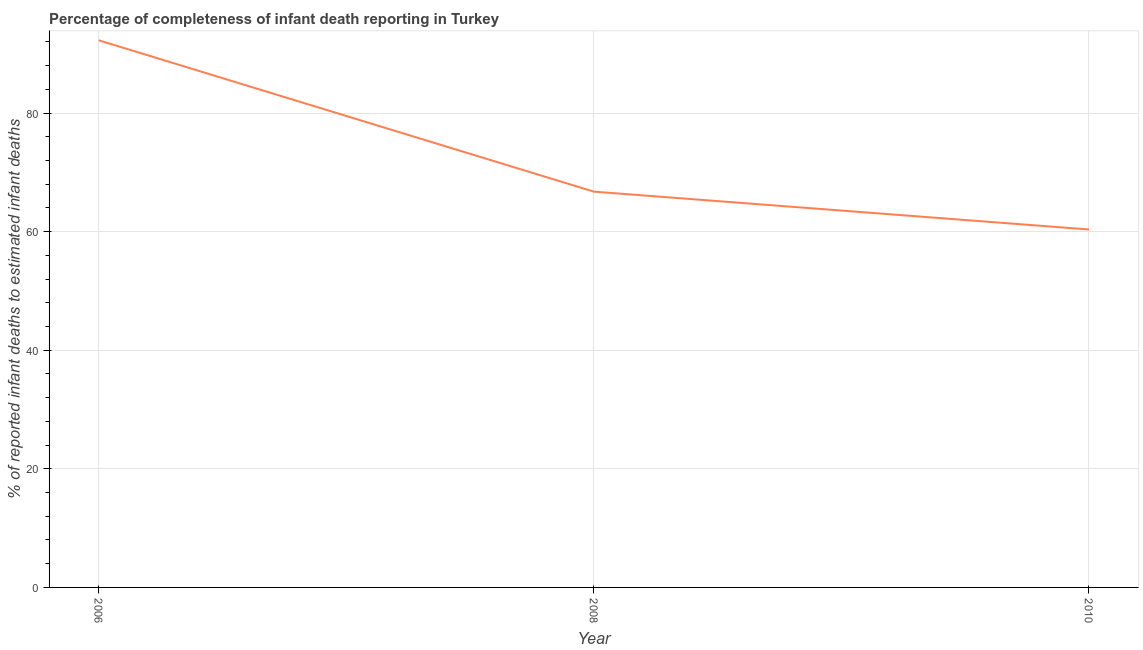What is the completeness of infant death reporting in 2006?
Give a very brief answer. 92.29. Across all years, what is the maximum completeness of infant death reporting?
Offer a very short reply. 92.29. Across all years, what is the minimum completeness of infant death reporting?
Offer a very short reply. 60.37. What is the sum of the completeness of infant death reporting?
Provide a short and direct response. 219.42. What is the difference between the completeness of infant death reporting in 2006 and 2010?
Provide a succinct answer. 31.91. What is the average completeness of infant death reporting per year?
Provide a short and direct response. 73.14. What is the median completeness of infant death reporting?
Keep it short and to the point. 66.76. What is the ratio of the completeness of infant death reporting in 2006 to that in 2008?
Offer a very short reply. 1.38. Is the completeness of infant death reporting in 2008 less than that in 2010?
Offer a very short reply. No. What is the difference between the highest and the second highest completeness of infant death reporting?
Offer a very short reply. 25.53. What is the difference between the highest and the lowest completeness of infant death reporting?
Keep it short and to the point. 31.91. Does the completeness of infant death reporting monotonically increase over the years?
Your answer should be very brief. No. How many years are there in the graph?
Make the answer very short. 3. What is the title of the graph?
Give a very brief answer. Percentage of completeness of infant death reporting in Turkey. What is the label or title of the X-axis?
Keep it short and to the point. Year. What is the label or title of the Y-axis?
Make the answer very short. % of reported infant deaths to estimated infant deaths. What is the % of reported infant deaths to estimated infant deaths in 2006?
Your answer should be very brief. 92.29. What is the % of reported infant deaths to estimated infant deaths of 2008?
Ensure brevity in your answer.  66.76. What is the % of reported infant deaths to estimated infant deaths in 2010?
Ensure brevity in your answer.  60.37. What is the difference between the % of reported infant deaths to estimated infant deaths in 2006 and 2008?
Your answer should be very brief. 25.53. What is the difference between the % of reported infant deaths to estimated infant deaths in 2006 and 2010?
Provide a succinct answer. 31.91. What is the difference between the % of reported infant deaths to estimated infant deaths in 2008 and 2010?
Provide a succinct answer. 6.38. What is the ratio of the % of reported infant deaths to estimated infant deaths in 2006 to that in 2008?
Your answer should be compact. 1.38. What is the ratio of the % of reported infant deaths to estimated infant deaths in 2006 to that in 2010?
Give a very brief answer. 1.53. What is the ratio of the % of reported infant deaths to estimated infant deaths in 2008 to that in 2010?
Ensure brevity in your answer.  1.11. 